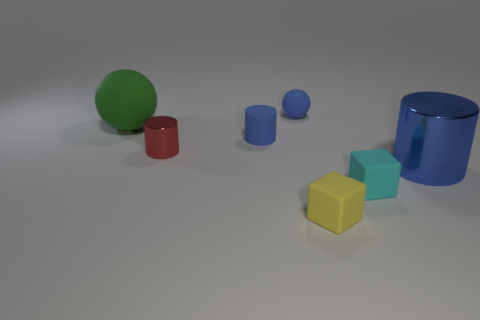Are the small blue sphere and the small cyan cube made of the same material?
Make the answer very short. Yes. There is a small yellow object that is in front of the large metallic object; how many small blue rubber things are to the left of it?
Your response must be concise. 2. Are there any tiny cyan things of the same shape as the tiny yellow rubber thing?
Give a very brief answer. Yes. Is the shape of the large object that is on the right side of the cyan matte thing the same as the metallic thing that is behind the big metal cylinder?
Your response must be concise. Yes. What is the shape of the blue object that is right of the blue rubber cylinder and left of the tiny cyan thing?
Provide a succinct answer. Sphere. Are there any cubes that have the same size as the cyan matte thing?
Provide a short and direct response. Yes. There is a large cylinder; is its color the same as the small matte thing behind the tiny rubber cylinder?
Keep it short and to the point. Yes. What material is the red thing?
Ensure brevity in your answer.  Metal. The sphere behind the large green matte object is what color?
Provide a short and direct response. Blue. What number of tiny balls have the same color as the large shiny object?
Give a very brief answer. 1. 